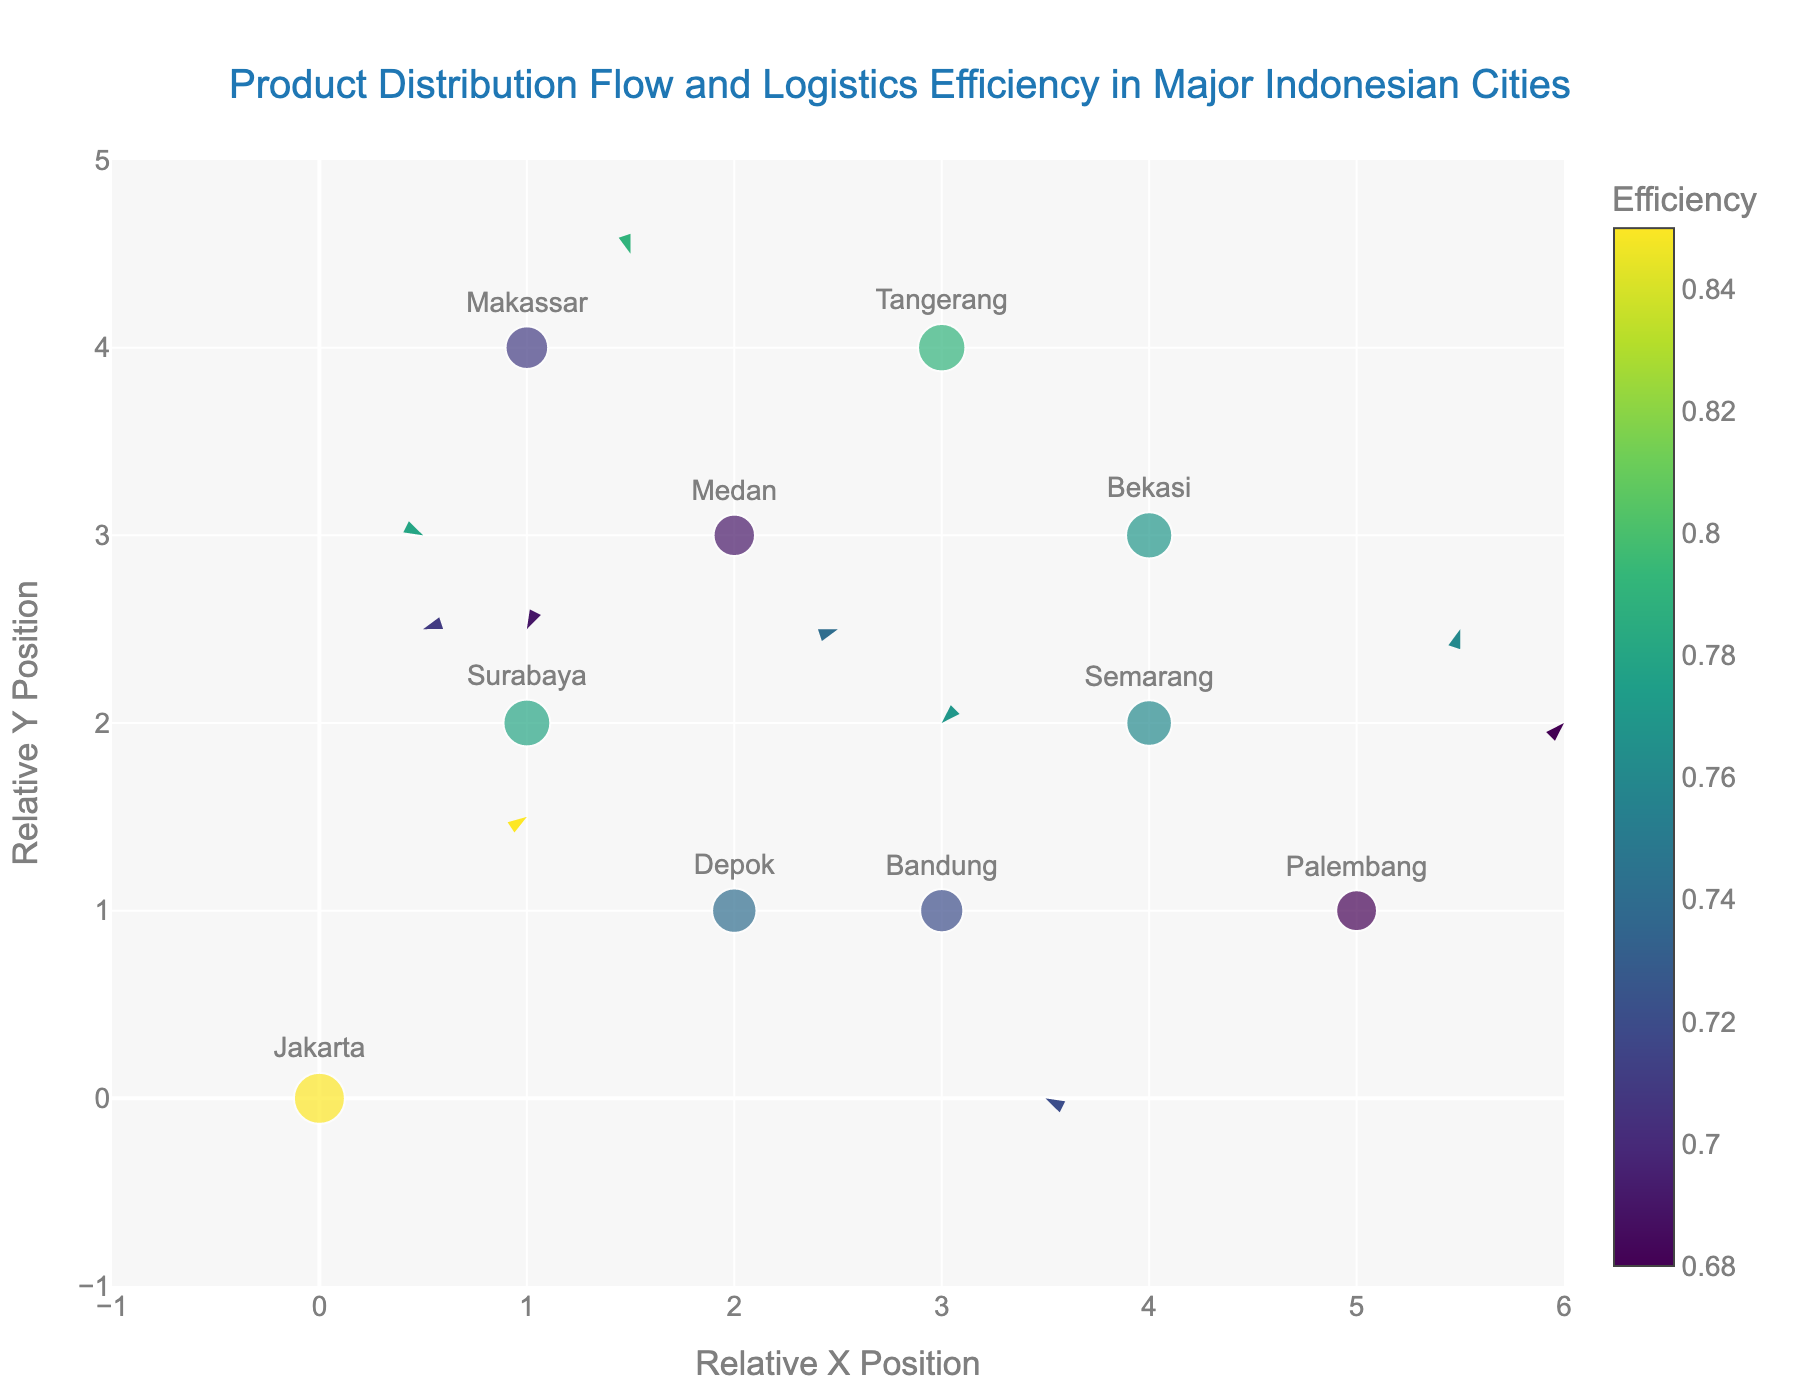What is the title of the figure? The title is usually positioned at the top of the figure. We can find it as "Product Distribution Flow and Logistics Efficiency in Major Indonesian Cities"
Answer: Product Distribution Flow and Logistics Efficiency in Major Indonesian Cities How many cities are represented in the figure? We can count the individual city names labeled on the plot. There are 10 cities mentioned: Jakarta, Surabaya, Bandung, Medan, Semarang, Makassar, Palembang, Tangerang, Depok, and Bekasi
Answer: 10 Which city has the highest logistics efficiency? By checking the size and color legend representing efficiency, the city with the largest size (marker) and most intense color (closer to the top of the Viridis scale) is Jakarta with an efficiency of 0.85
Answer: Jakarta What is the relative position (x, y) of Tangerang on the plot? Look at the markers with city labels, locate Tangerang and read off its coordinates. Tangerang is positioned at (3, 4)
Answer: (3, 4) What are the directions and magnitudes of the movement vectors for Depok? For Depok, find the marker and check the vector information. The vector is (1, 3) originating from (2, 1). To find the magnitude, use the Pythagorean theorem: sqrt(1^2 + 3^2) = sqrt(10) ≈ 3.16
Answer: Direction: (1, 3), Magnitude: 3.16 Compare the logistics efficiency of Medan and Semarang. Which city is more efficient and by how much? Checking the figure, Medan has an efficiency of 0.69, while Semarang has 0.76. Subtract the lower efficiency from the higher one: 0.76 - 0.69 = 0.07
Answer: Semarang by 0.07 Which city has the lowest logistics efficiency? By examining the size and color of the plotted markers, Palembang is shown with the lowest efficiency of 0.68
Answer: Palembang What is the vector direction and efficiency ranking of Surabaya? Surabaya's vector is (-1, 2) originating from (1, 2), and to rank the city's efficiency, observe all efficiencies. Surabaya has 0.78, which ranks second highest after Jakarta
Answer: Direction: (-1, 2), Efficiency Rank: 2nd What is the average logistics efficiency across all cities? Sum all efficiency values and divide by the number of cities. (0.85 + 0.78 + 0.72 + 0.69 + 0.76 + 0.71 + 0.68 + 0.79 + 0.74 + 0.77) / 10 = 7.49 / 10 = 0.749
Answer: 0.749 Which cities have vector directions pointing south-west? Vectors pointing south-west have both negative u and v values. Observing the plot, Medan (-2, -1) and Bekasi (-2, -2) have vectors pointing south-west
Answer: Medan and Bekasi 